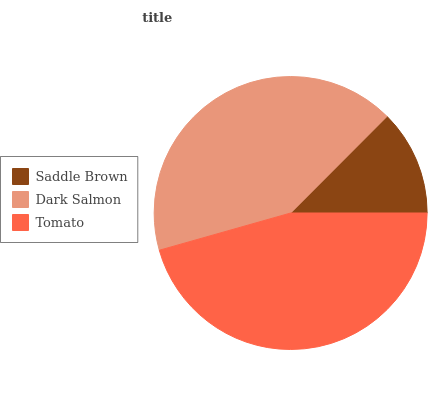Is Saddle Brown the minimum?
Answer yes or no. Yes. Is Tomato the maximum?
Answer yes or no. Yes. Is Dark Salmon the minimum?
Answer yes or no. No. Is Dark Salmon the maximum?
Answer yes or no. No. Is Dark Salmon greater than Saddle Brown?
Answer yes or no. Yes. Is Saddle Brown less than Dark Salmon?
Answer yes or no. Yes. Is Saddle Brown greater than Dark Salmon?
Answer yes or no. No. Is Dark Salmon less than Saddle Brown?
Answer yes or no. No. Is Dark Salmon the high median?
Answer yes or no. Yes. Is Dark Salmon the low median?
Answer yes or no. Yes. Is Tomato the high median?
Answer yes or no. No. Is Saddle Brown the low median?
Answer yes or no. No. 